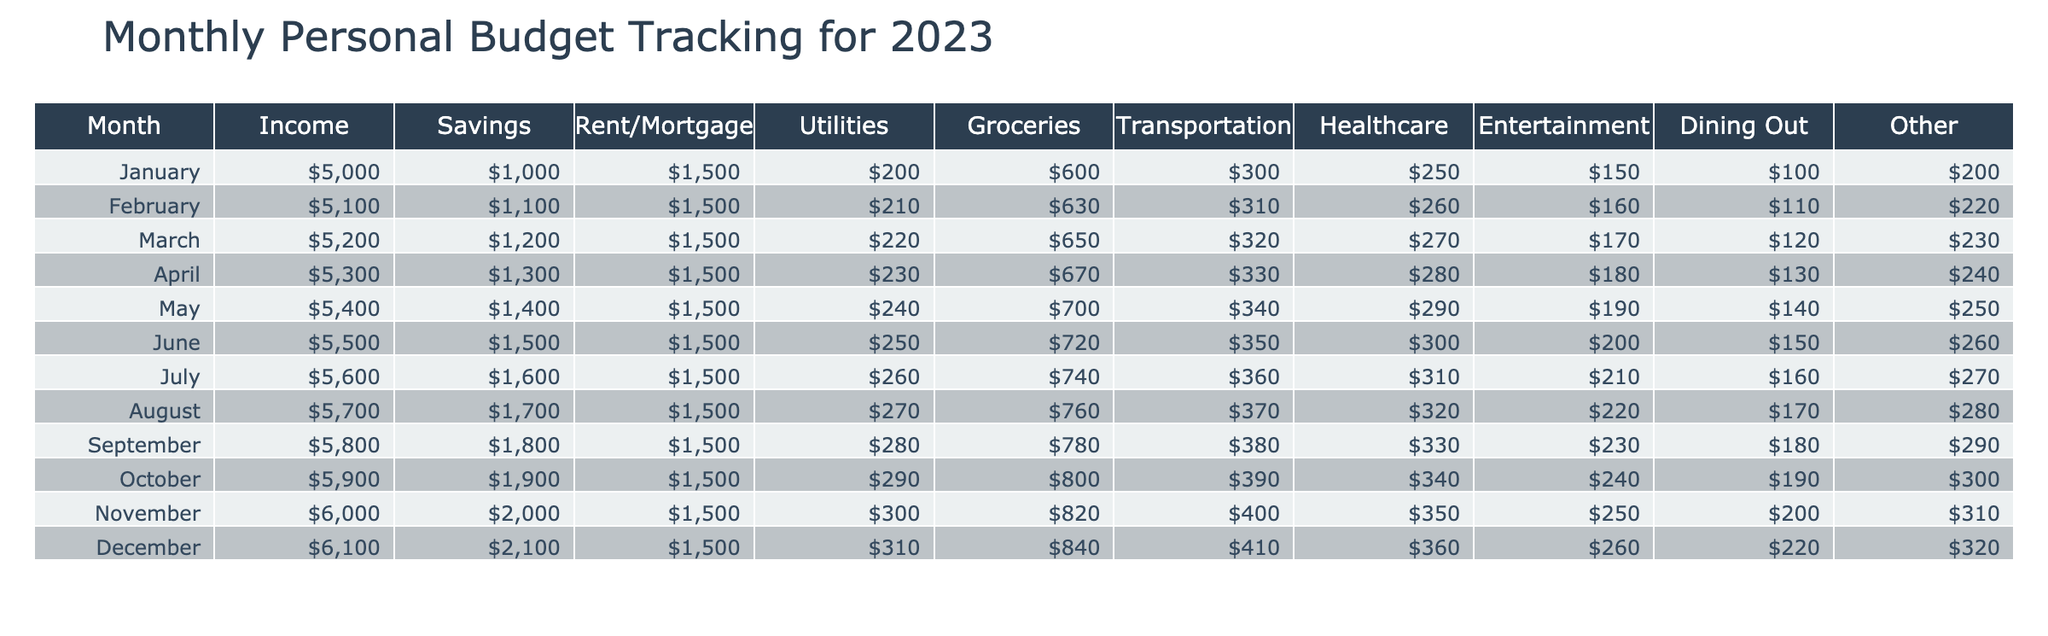What was the total income for the month of October? The table shows that the income for October is $5900.
Answer: $5900 In which month did the healthcare expenses reach $400? Looking through the table, the healthcare expenses reach $400 in November.
Answer: November What is the average savings from January to March? To find the average savings from January to March, we sum the savings for these months: $1000 + $1100 + $1200 = $3300. Then, divide by 3 (number of months), so $3300 / 3 = $1100.
Answer: $1100 Was there an increase in rent/mortgage expenses from February to March? The rent/mortgage in February is $1500 and in March is also $1500, indicating that there was no increase.
Answer: No What is the total amount spent on dining out from May to August? First, identify the dining out expenses from May to August: May is $190, June is $200, July is $210, and August is $220. Add these values: $190 + $200 + $210 + $220 = $820.
Answer: $820 In which month did the highest savings occur, and what was that amount? The highest savings occur in December, where the savings amount is $2100, according to the table.
Answer: December, $2100 What are the combined total expenses for utilities and transportation in September? For September, utilities are $280 and transportation is $380. Combine these two amounts: $280 + $380 = $660 for the total expenses.
Answer: $660 Did the average groceries expenditure increase from the first half of the year (January to June) to the second half (July to December)? First half groceries (January to June totals): $600 + $630 + $650 + $670 + $700 + $720 = $4080; average = $4080 / 6 = $680. Second half groceries (July to December totals): $740 + $760 + $780 + $800 + $820 + $840 = $4620; average = $4620 / 6 = $770. Since $770 is greater than $680, the average did increase.
Answer: Yes 